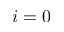<formula> <loc_0><loc_0><loc_500><loc_500>i = 0</formula> 